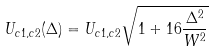<formula> <loc_0><loc_0><loc_500><loc_500>U _ { c 1 , c 2 } ( \Delta ) = U _ { c 1 , c 2 } \sqrt { 1 + 1 6 \frac { \Delta ^ { 2 } } { W ^ { 2 } } }</formula> 